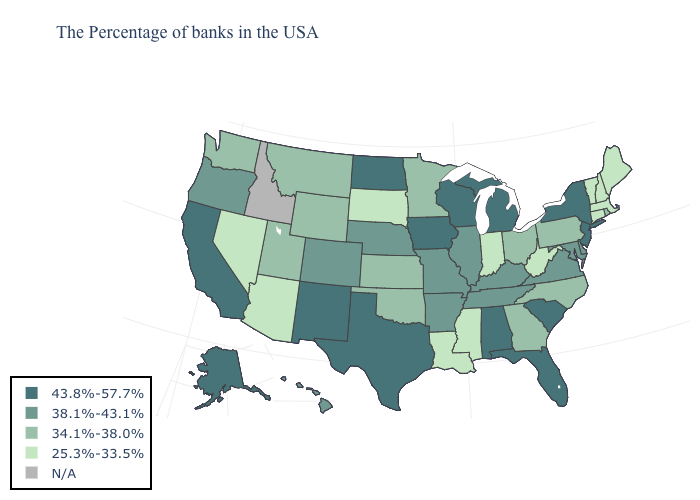Which states have the lowest value in the South?
Keep it brief. West Virginia, Mississippi, Louisiana. What is the value of Montana?
Short answer required. 34.1%-38.0%. Does the map have missing data?
Answer briefly. Yes. Does Hawaii have the highest value in the West?
Keep it brief. No. Does Virginia have the highest value in the USA?
Keep it brief. No. Among the states that border North Dakota , does Montana have the lowest value?
Be succinct. No. Which states have the lowest value in the USA?
Keep it brief. Maine, Massachusetts, New Hampshire, Vermont, Connecticut, West Virginia, Indiana, Mississippi, Louisiana, South Dakota, Arizona, Nevada. Is the legend a continuous bar?
Give a very brief answer. No. Which states have the lowest value in the West?
Give a very brief answer. Arizona, Nevada. Which states have the lowest value in the USA?
Short answer required. Maine, Massachusetts, New Hampshire, Vermont, Connecticut, West Virginia, Indiana, Mississippi, Louisiana, South Dakota, Arizona, Nevada. Among the states that border New Jersey , which have the highest value?
Short answer required. New York. What is the lowest value in the South?
Short answer required. 25.3%-33.5%. What is the lowest value in the West?
Answer briefly. 25.3%-33.5%. How many symbols are there in the legend?
Be succinct. 5. 